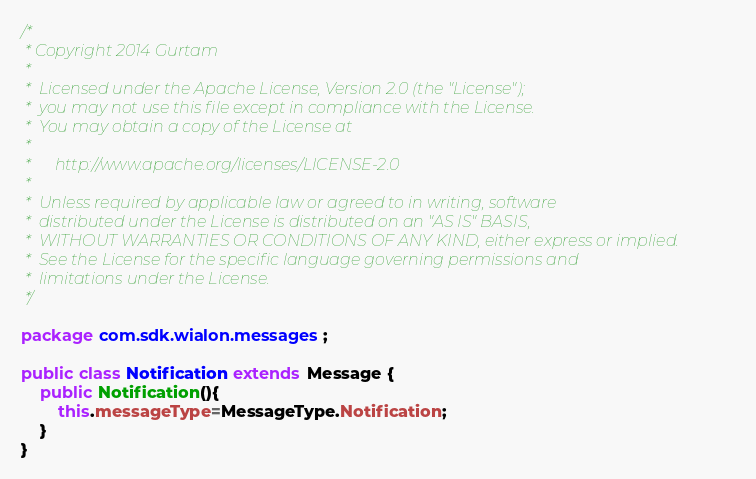Convert code to text. <code><loc_0><loc_0><loc_500><loc_500><_Java_>/*
 * Copyright 2014 Gurtam
 *
 * 	Licensed under the Apache License, Version 2.0 (the "License");
 * 	you may not use this file except in compliance with the License.
 * 	You may obtain a copy of the License at
 *
 * 		http://www.apache.org/licenses/LICENSE-2.0
 *
 * 	Unless required by applicable law or agreed to in writing, software
 * 	distributed under the License is distributed on an "AS IS" BASIS,
 * 	WITHOUT WARRANTIES OR CONDITIONS OF ANY KIND, either express or implied.
 * 	See the License for the specific language governing permissions and
 * 	limitations under the License.
 */

package com.sdk.wialon.messages;

public class Notification extends Message {
	public Notification(){
		this.messageType=MessageType.Notification;
	}
}
</code> 